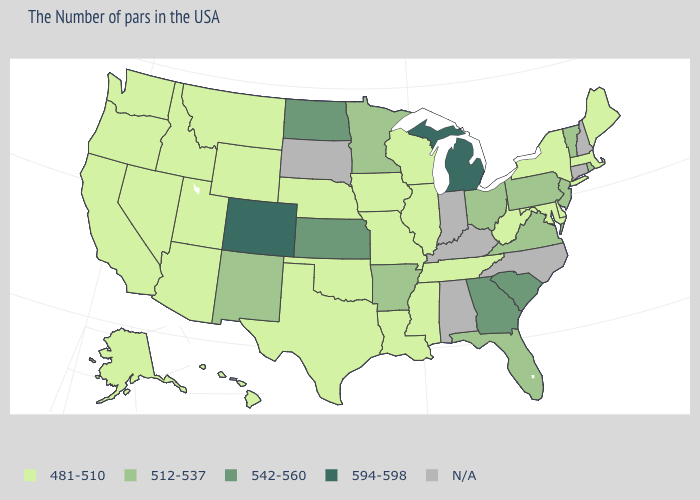Is the legend a continuous bar?
Answer briefly. No. What is the lowest value in the USA?
Give a very brief answer. 481-510. Which states have the lowest value in the USA?
Short answer required. Maine, Massachusetts, New York, Delaware, Maryland, West Virginia, Tennessee, Wisconsin, Illinois, Mississippi, Louisiana, Missouri, Iowa, Nebraska, Oklahoma, Texas, Wyoming, Utah, Montana, Arizona, Idaho, Nevada, California, Washington, Oregon, Alaska, Hawaii. What is the highest value in the USA?
Be succinct. 594-598. What is the highest value in states that border Florida?
Quick response, please. 542-560. Does Nevada have the highest value in the West?
Concise answer only. No. Does Massachusetts have the lowest value in the USA?
Answer briefly. Yes. Name the states that have a value in the range 594-598?
Write a very short answer. Michigan, Colorado. Name the states that have a value in the range 542-560?
Write a very short answer. South Carolina, Georgia, Kansas, North Dakota. Among the states that border New York , does Massachusetts have the lowest value?
Keep it brief. Yes. 